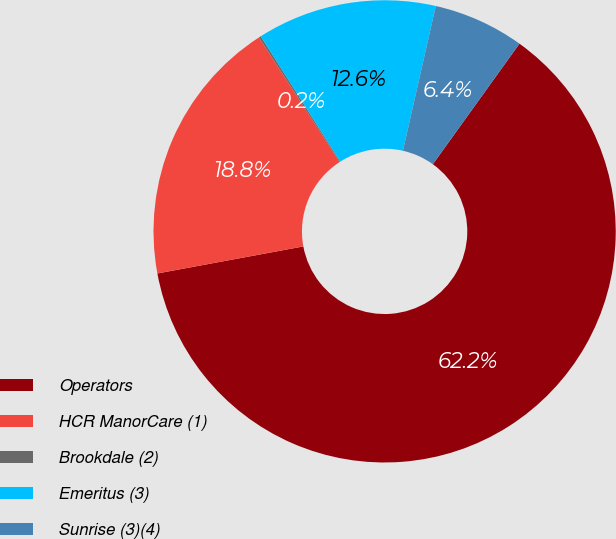Convert chart to OTSL. <chart><loc_0><loc_0><loc_500><loc_500><pie_chart><fcel>Operators<fcel>HCR ManorCare (1)<fcel>Brookdale (2)<fcel>Emeritus (3)<fcel>Sunrise (3)(4)<nl><fcel>62.17%<fcel>18.76%<fcel>0.15%<fcel>12.56%<fcel>6.36%<nl></chart> 